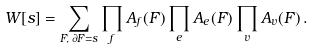<formula> <loc_0><loc_0><loc_500><loc_500>W [ s ] = \sum _ { F , \, \partial F = s } \prod _ { f } A _ { f } ( F ) \prod _ { e } A _ { e } ( F ) \prod _ { v } A _ { v } ( F ) \, .</formula> 